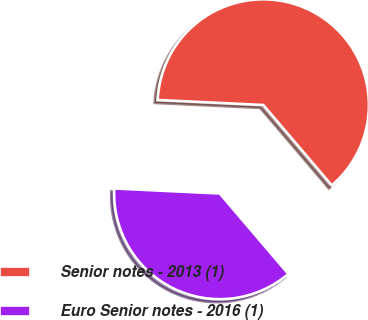Convert chart. <chart><loc_0><loc_0><loc_500><loc_500><pie_chart><fcel>Senior notes - 2013 (1)<fcel>Euro Senior notes - 2016 (1)<nl><fcel>63.01%<fcel>36.99%<nl></chart> 